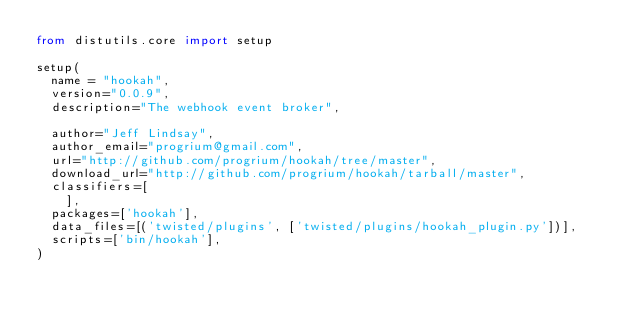<code> <loc_0><loc_0><loc_500><loc_500><_Python_>from distutils.core import setup

setup(
  name = "hookah",
  version="0.0.9",
  description="The webhook event broker",
  
  author="Jeff Lindsay",
  author_email="progrium@gmail.com",
  url="http://github.com/progrium/hookah/tree/master",
  download_url="http://github.com/progrium/hookah/tarball/master",
  classifiers=[
    ],
  packages=['hookah'],
  data_files=[('twisted/plugins', ['twisted/plugins/hookah_plugin.py'])],
  scripts=['bin/hookah'],
)
</code> 